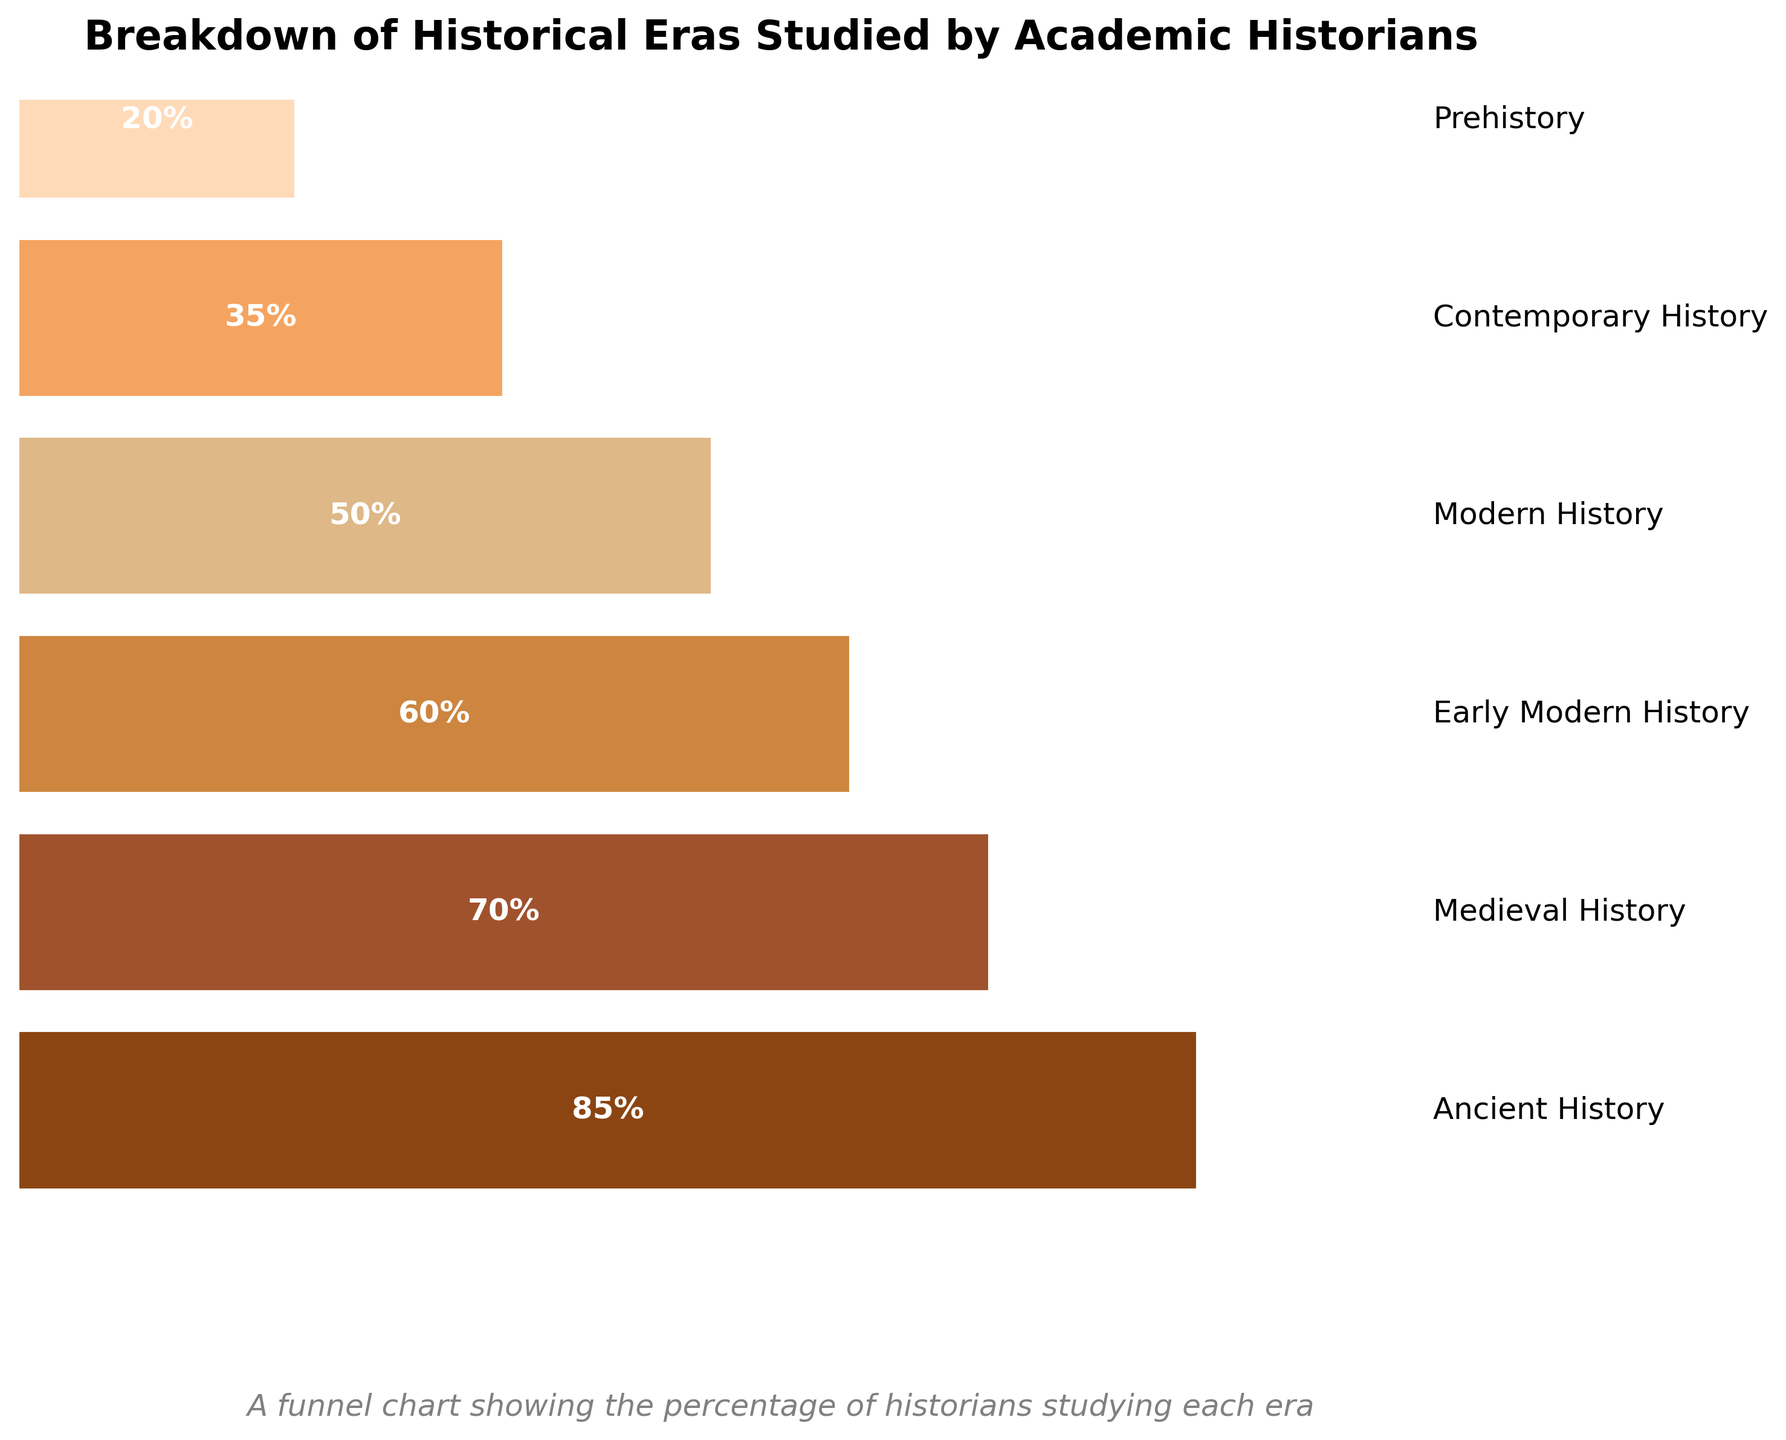What is the title of the chart? The title is usually placed at the top of the chart. By looking at the topmost part, we can see that the title is "Breakdown of Historical Eras Studied by Academic Historians".
Answer: Breakdown of Historical Eras Studied by Academic Historians How many historical eras are represented in the chart? The chart contains bars for each historical era. By counting the bars, we can see there are six historical eras.
Answer: Six Which historical era is studied by the highest percentage of historians? By looking at the highest bar, you can see the era corresponding to this bar. The highest bar is for "Ancient History" with 85%.
Answer: Ancient History What is the difference in the percentage of historians studying Ancient History and Early Modern History? The percentage of historians studying Ancient History is 85%, and for Early Modern History, it is 60%. Subtracting 60 from 85 gives us the difference.
Answer: 25% What is the total percentage of historians studying either Modern History or Contemporary History? The percentage of historians studying Modern History is 50%, and for Contemporary History, it is 35%. Adding these two percentages together gives us the total.
Answer: 85% Which era is studied by fewer historians, Prehistory or Contemporary History? By comparing the heights of the bars for Prehistory and Contemporary History, you see that Prehistory has a percentage of 20%, and Contemporary History has 35%. Since 20% is less than 35%, fewer historians study Prehistory.
Answer: Prehistory Is the percentage of historians studying Modern History greater than or equal to the percentage of historians studying Medieval History? The percentage of historians studying Modern History is 50%, and for Medieval History, it is 70%. Since 50% is less than 70%, the percentage of historians studying Modern History is not greater than or equal to that of Medieval History.
Answer: No How many bars in the chart represent an era studied by at least half of the historians? An era studied by at least half of the historians means percentages of 50% or more. By counting the bars with percentages equal to or greater than 50, we find three bars meet this criterion: Ancient History - 85%, Medieval History - 70%, and Early Modern History - 60%.
Answer: Three If the percentages were ordered from highest to lowest, which era would be in the middle? Ordering the percentages from highest to lowest: 85% (Ancient History), 70% (Medieval History), 60% (Early Modern History), 50% (Modern History), 35% (Contemporary History), 20% (Prehistory). The middle value is the third highest, which corresponds to Early Modern History.
Answer: Early Modern History 